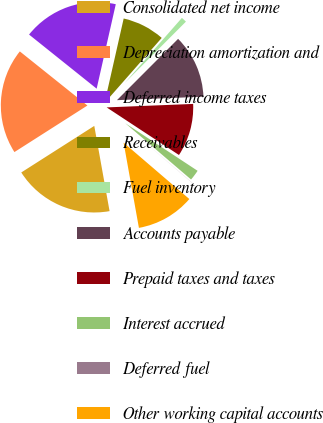Convert chart to OTSL. <chart><loc_0><loc_0><loc_500><loc_500><pie_chart><fcel>Consolidated net income<fcel>Depreciation amortization and<fcel>Deferred income taxes<fcel>Receivables<fcel>Fuel inventory<fcel>Accounts payable<fcel>Prepaid taxes and taxes<fcel>Interest accrued<fcel>Deferred fuel<fcel>Other working capital accounts<nl><fcel>18.79%<fcel>19.78%<fcel>17.8%<fcel>7.93%<fcel>1.01%<fcel>11.88%<fcel>9.9%<fcel>2.0%<fcel>0.02%<fcel>10.89%<nl></chart> 